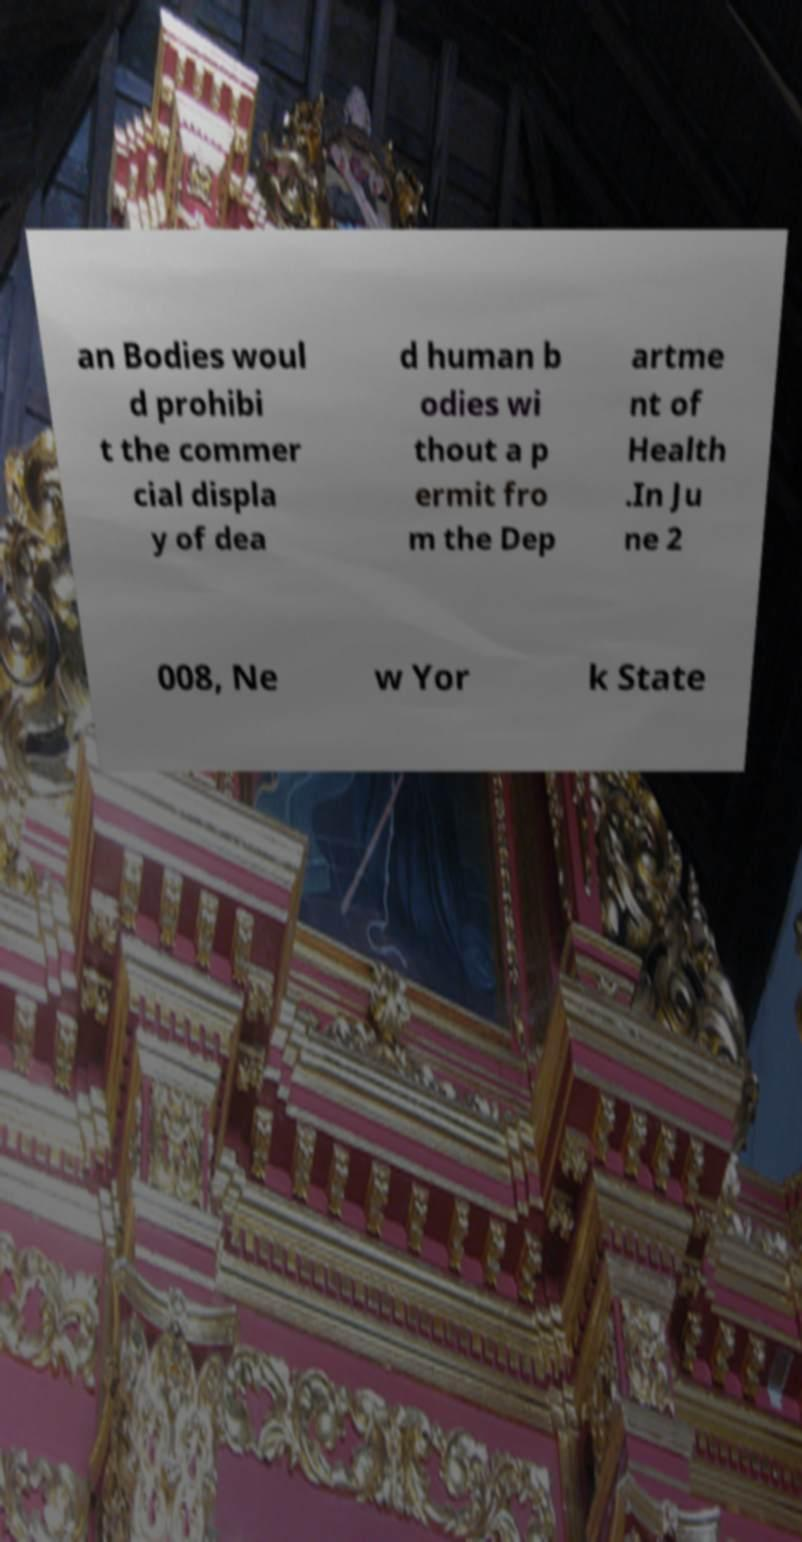Can you read and provide the text displayed in the image?This photo seems to have some interesting text. Can you extract and type it out for me? an Bodies woul d prohibi t the commer cial displa y of dea d human b odies wi thout a p ermit fro m the Dep artme nt of Health .In Ju ne 2 008, Ne w Yor k State 